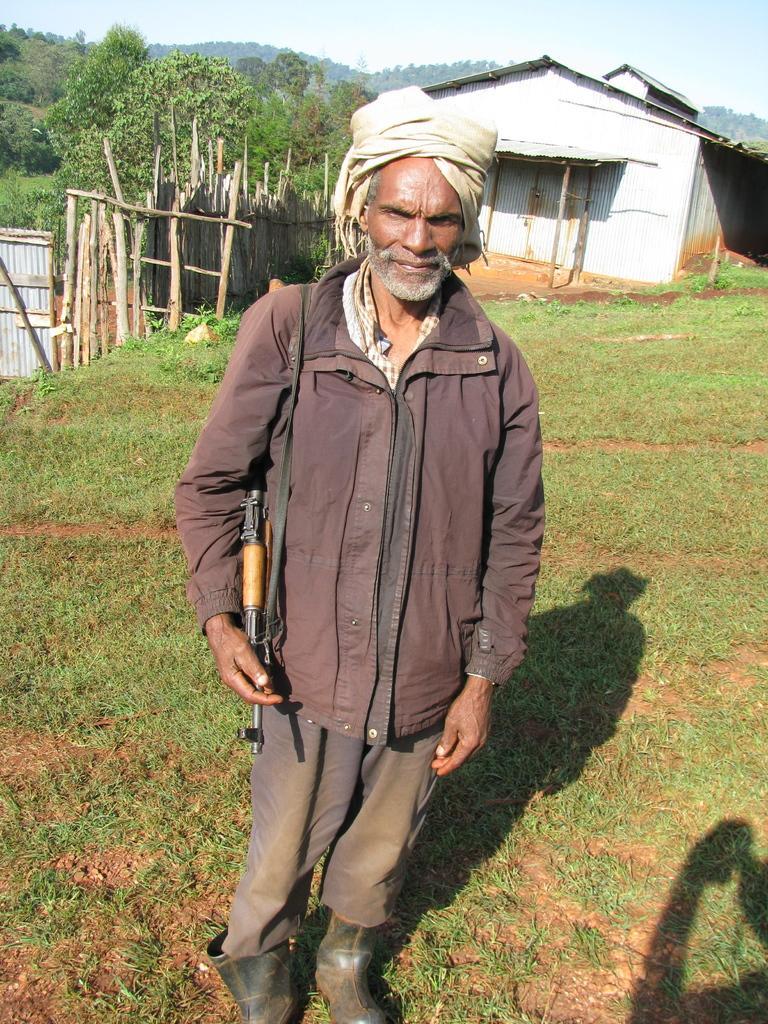Please provide a concise description of this image. In this picture I can see a man standing and he is holding a gun and I can see grass on the ground and a house in the back and I can see trees and a cloudy sky. 